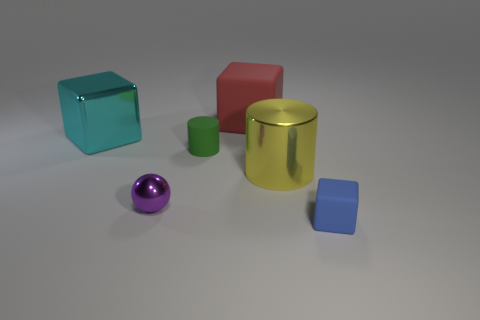Subtract all metallic cubes. How many cubes are left? 2 Subtract all cyan blocks. How many blocks are left? 2 Add 1 large matte cubes. How many objects exist? 7 Subtract all red cubes. How many green cylinders are left? 1 Subtract 1 spheres. How many spheres are left? 0 Subtract all brown matte cubes. Subtract all small purple shiny objects. How many objects are left? 5 Add 4 blue objects. How many blue objects are left? 5 Add 6 tiny blue objects. How many tiny blue objects exist? 7 Subtract 0 red cylinders. How many objects are left? 6 Subtract all balls. How many objects are left? 5 